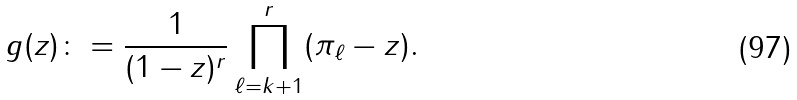<formula> <loc_0><loc_0><loc_500><loc_500>g ( z ) \colon = \frac { 1 } { ( 1 - z ) ^ { r } } \prod _ { \ell = k + 1 } ^ { r } ( \pi _ { \ell } - z ) .</formula> 